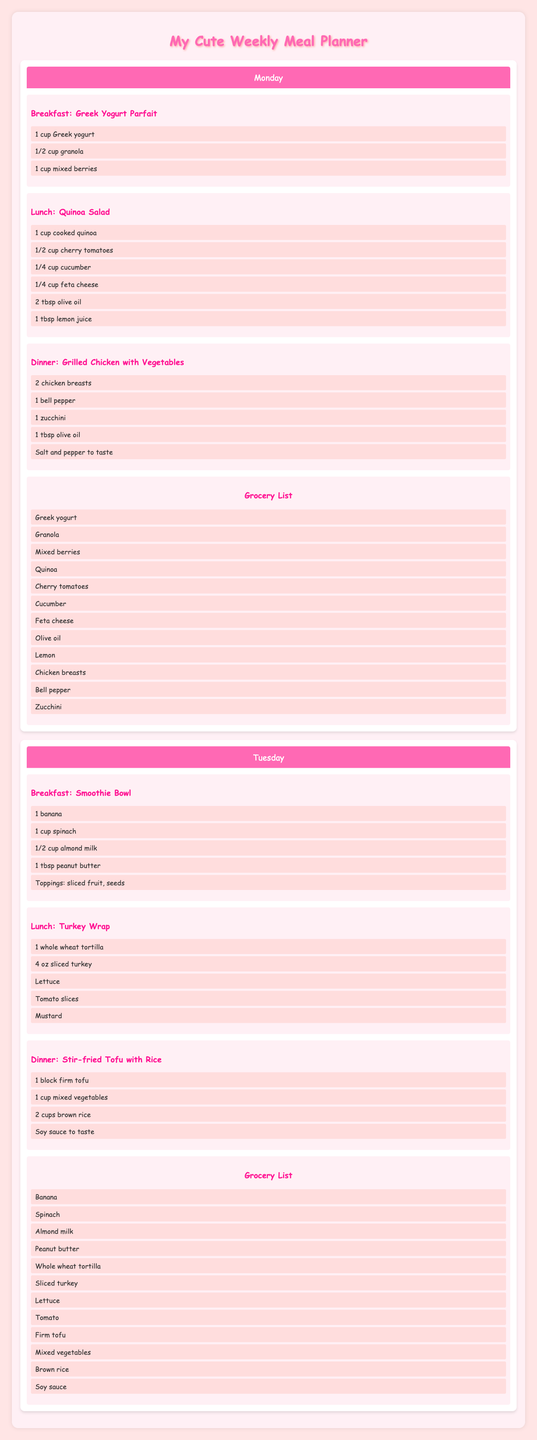What is the breakfast for Thursday? The table shows the meals for each day, and for Thursday, the breakfast listed is "Avocado Toast."
Answer: Avocado Toast How many ingredients are needed for the Lentil Soup on Wednesday? To determine this, I check the number of ingredients listed under the Lentil Soup in the Wednesday meal section. There are 5 ingredients: lentils, carrot, onion, celery, and vegetable broth.
Answer: 5 Is there a vegetarian dinner option on Saturday? In the Saturday meals, the dinner is "Stuffed Bell Peppers," which can be considered vegetarian as it primarily consists of vegetables and beans.
Answer: Yes What are the total number of ingredients for lunch across the week? I look at the lunch sections for each day. The counts are: Quinoa Salad (6 ingredients), Turkey Wrap (5), Lentil Soup (5), Caprese Salad (5), Chicken Caesar Salad (5), Tuna Salad Sandwich (5), Veggie Burger (5). Adding these together gives 36 total ingredients.
Answer: 36 Which meal has the most ingredients on Tuesday? I compare the breakfast, lunch, and dinner meals for Tuesday. The breakfast (Smoothie Bowl) has 5, lunch (Turkey Wrap) has 5, and dinner (Stir-fried Tofu with Rice) contains 4. Both the breakfast and lunch have the most ingredients, tied at 5.
Answer: Smoothie Bowl and Turkey Wrap What types of fruits are included in the breakfast meals throughout the week? Checking each breakfast entry, I find Greek yogurt parfait (mixed berries), smoothie bowl (banana), oatmeal (apple), fruit salad (strawberries, grapes, orange, banana). Collectively, the fruits are mixed berries, banana, apple, strawberries, grapes, and orange.
Answer: Mixed berries, banana, apple, strawberries, grapes, orange Is Chicken used in any meal on the menu? Looking through all the meals listed, I find "Grilled Chicken with Vegetables" on Monday and "Chicken Caesar Salad" on Friday. Therefore, chicken is indeed included in these meals.
Answer: Yes How many meals contain cheese in the menu? I scan the meals for any that include cheese. The meals that contain cheese are "Quinoa Salad" (feta cheese), "Caprese Salad" (mozzarella cheese), and "Egg and Spinach Breakfast Muffins" (cheese). Hence, the total is 3 meals.
Answer: 3 What is the total number of breakfast options listed for the week? There are breakfast entries for each day, totaling Monday, Tuesday, Wednesday, Thursday, Friday, Saturday, and Sunday, which adds up to 7 breakfast options.
Answer: 7 